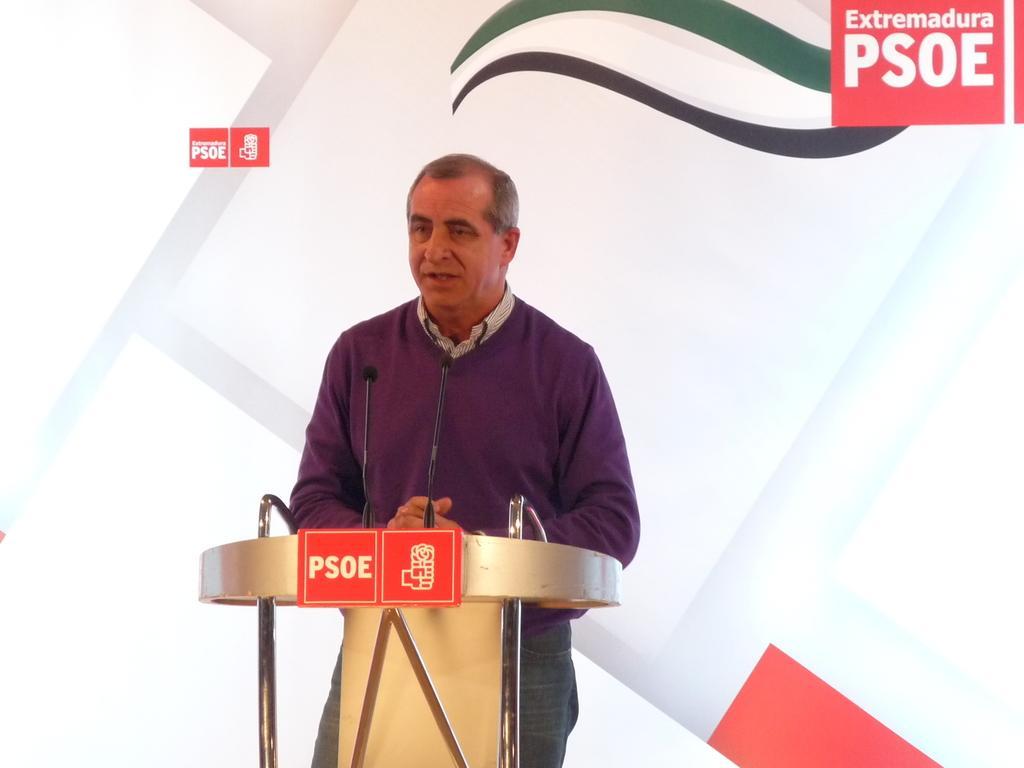Can you describe this image briefly? In the foreground of this picture, there is a man standing near a podium along with mics. In the background, there is a white banner and few logos on it. 